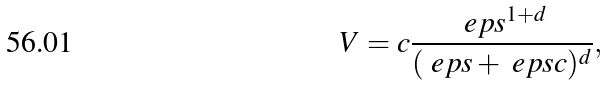Convert formula to latex. <formula><loc_0><loc_0><loc_500><loc_500>V = c \frac { \ e p s ^ { 1 + d } } { ( \ e p s + \ e p s c ) ^ { d } } ,</formula> 